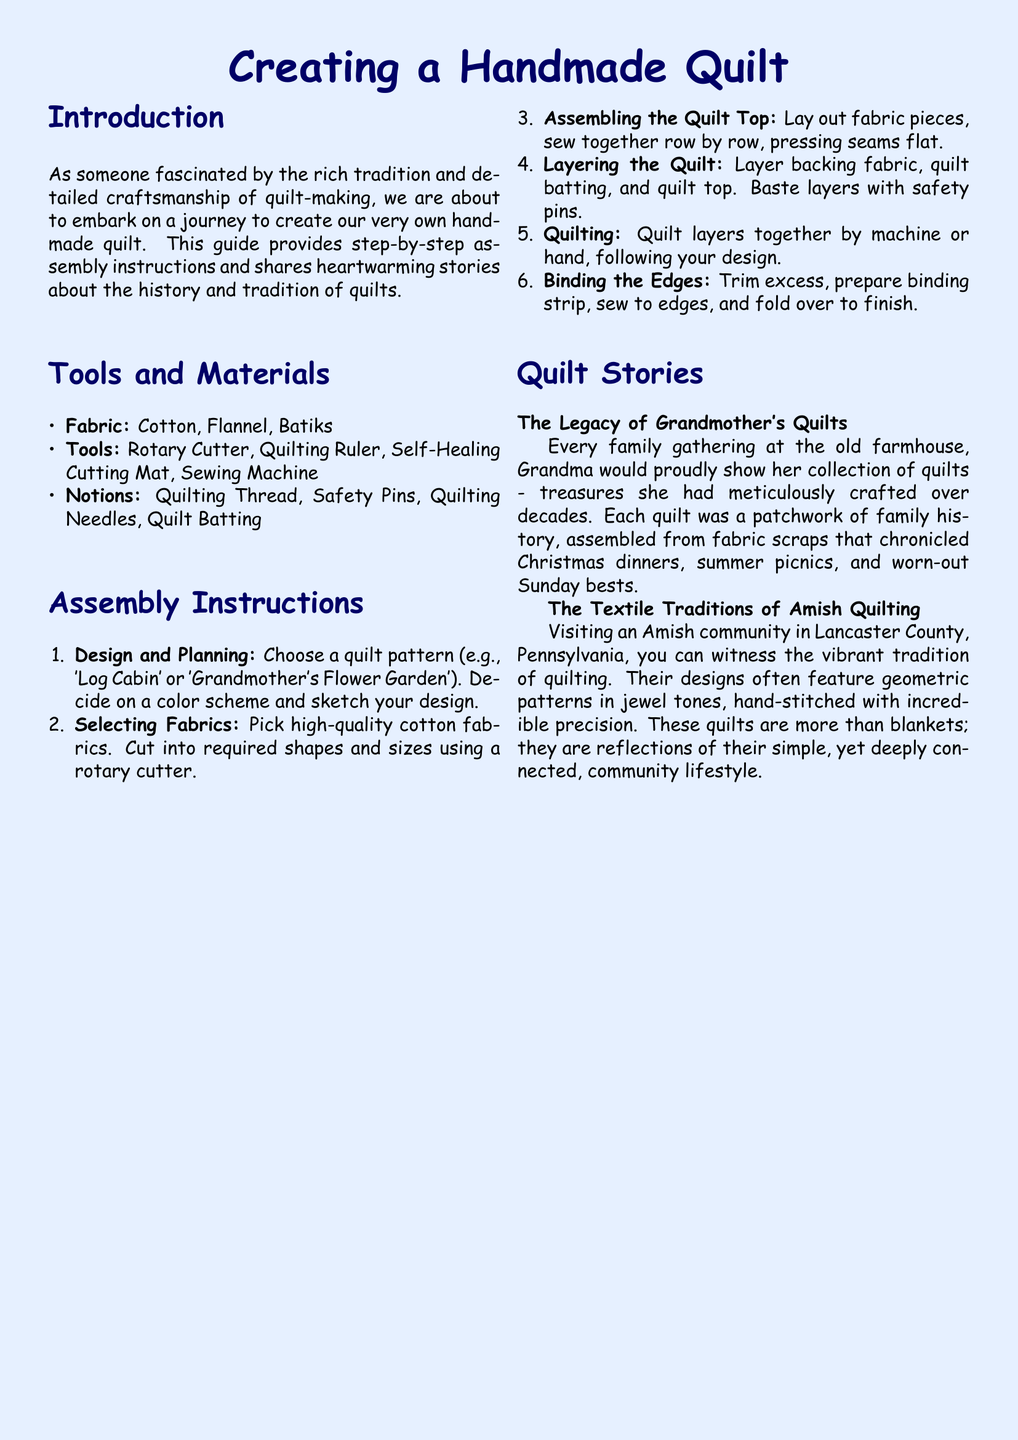what are the materials needed for making a quilt? The materials needed for making a quilt are listed under the "Tools and Materials" section, which includes fabric types, tools, and notions.
Answer: Cotton, Flannel, Batiks, Rotary Cutter, Quilting Ruler, Self-Healing Cutting Mat, Sewing Machine, Quilting Thread, Safety Pins, Quilting Needles, Quilt Batting how many steps are there in the assembly instructions? The number of steps in the assembly instructions can be counted from the "Assembly Instructions" section.
Answer: Six what quilt pattern is mentioned as an example? The document provides examples of quilt patterns in the "Assembly Instructions" section.
Answer: Log Cabin, Grandmother's Flower Garden which tradition does the document highlight in the quilt stories? The quilt stories section discusses a specific tradition related to quilting, which is found in the text.
Answer: Amish Quilting what is the first step in creating a handmade quilt? The first step in the assembly instructions outlines the initial action required for quilt-making.
Answer: Design and Planning what type of fabric is recommended when selecting fabrics for quilting? The recommendation can be found in the "Selecting Fabrics" point of the assembly instructions.
Answer: High-quality cotton fabrics 